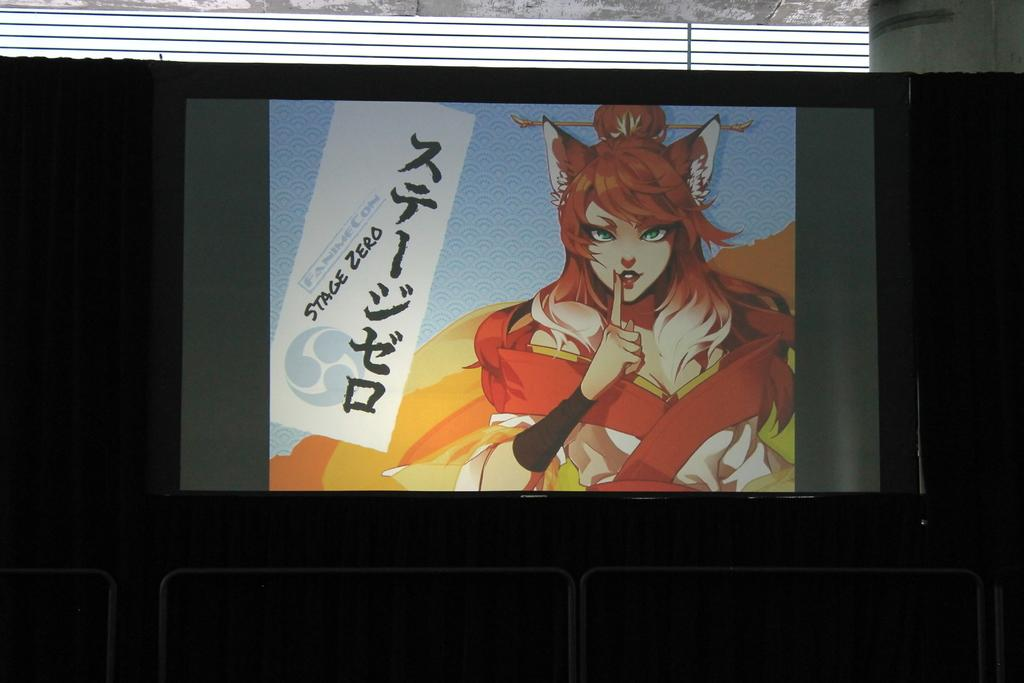What type of visual is depicted in the image? The image appears to be a poster. What can be seen on the poster? Unfortunately, the provided facts do not give any information about the content of the poster. Are there any objects or structures visible under the board in the image? Yes, there are barriers under the board in the image. What type of silk is draped over the chair in the image? There is no chair or silk present in the image. How many clams are visible on the poster in the image? There is no information about the content of the poster, so it is impossible to determine if there are any clams present. 